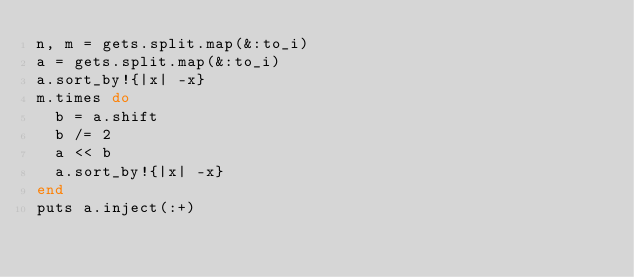<code> <loc_0><loc_0><loc_500><loc_500><_Ruby_>n, m = gets.split.map(&:to_i)
a = gets.split.map(&:to_i)
a.sort_by!{|x| -x}
m.times do
  b = a.shift
  b /= 2
  a << b
  a.sort_by!{|x| -x}  
end
puts a.inject(:+)</code> 